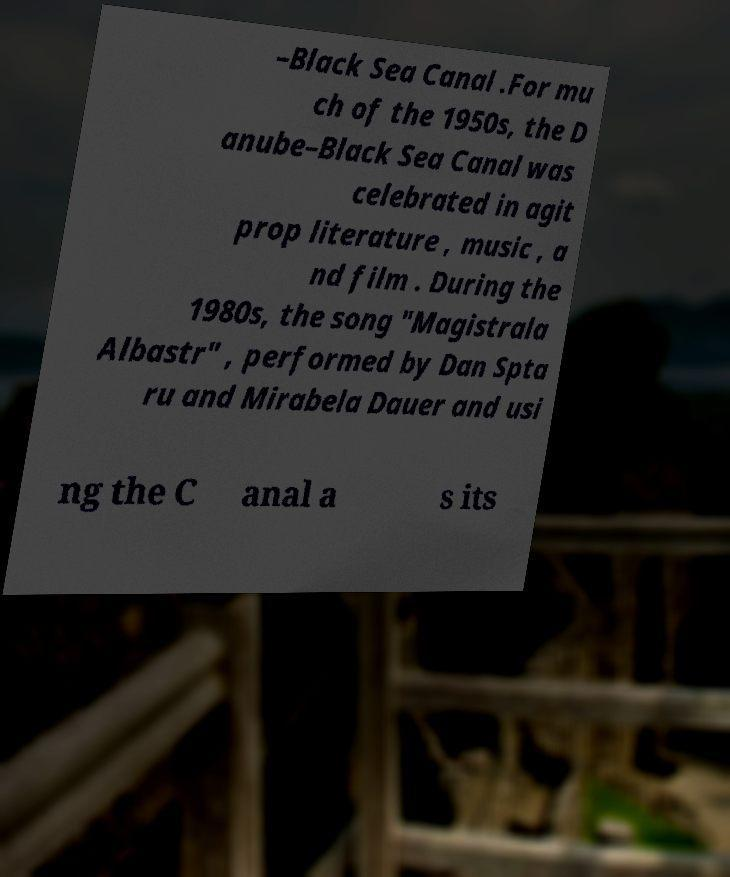Could you assist in decoding the text presented in this image and type it out clearly? –Black Sea Canal .For mu ch of the 1950s, the D anube–Black Sea Canal was celebrated in agit prop literature , music , a nd film . During the 1980s, the song "Magistrala Albastr" , performed by Dan Spta ru and Mirabela Dauer and usi ng the C anal a s its 